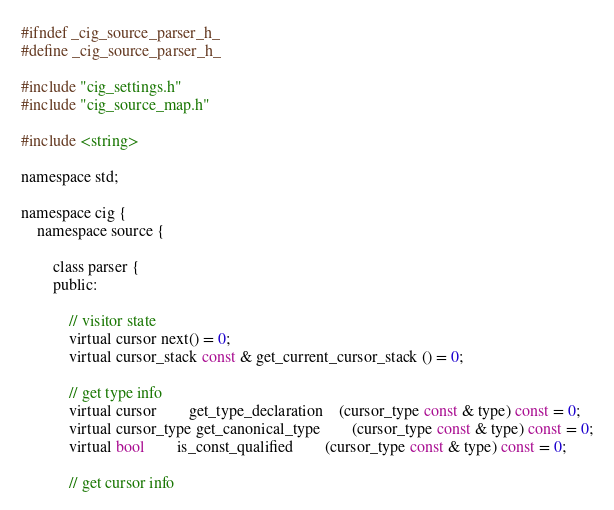<code> <loc_0><loc_0><loc_500><loc_500><_C_>#ifndef _cig_source_parser_h_
#define _cig_source_parser_h_

#include "cig_settings.h"
#include "cig_source_map.h"

#include <string>

namespace std;

namespace cig {
	namespace source {

		class parser {
		public:

			// visitor state
			virtual cursor next() = 0;
			virtual cursor_stack const & get_current_cursor_stack () = 0;

			// get type info
			virtual cursor 		get_type_declaration 	(cursor_type const & type) const = 0;
			virtual cursor_type get_canonical_type 		(cursor_type const & type) const = 0;
			virtual bool 		is_const_qualified 		(cursor_type const & type) const = 0;

			// get cursor info</code> 